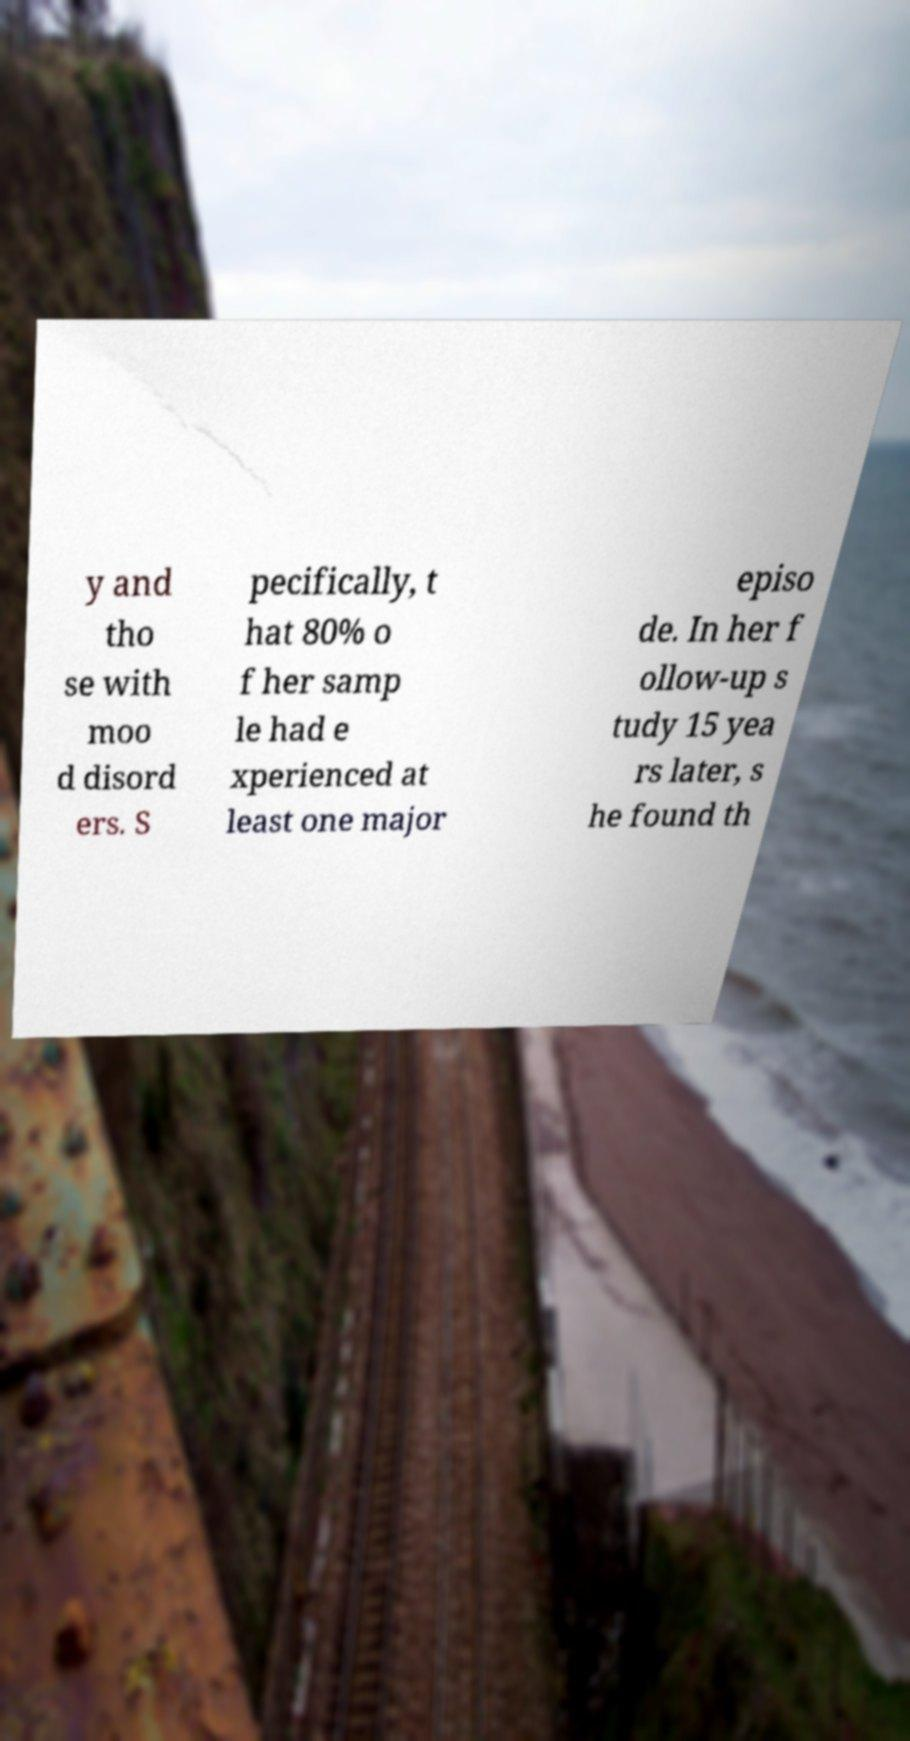Could you assist in decoding the text presented in this image and type it out clearly? y and tho se with moo d disord ers. S pecifically, t hat 80% o f her samp le had e xperienced at least one major episo de. In her f ollow-up s tudy 15 yea rs later, s he found th 